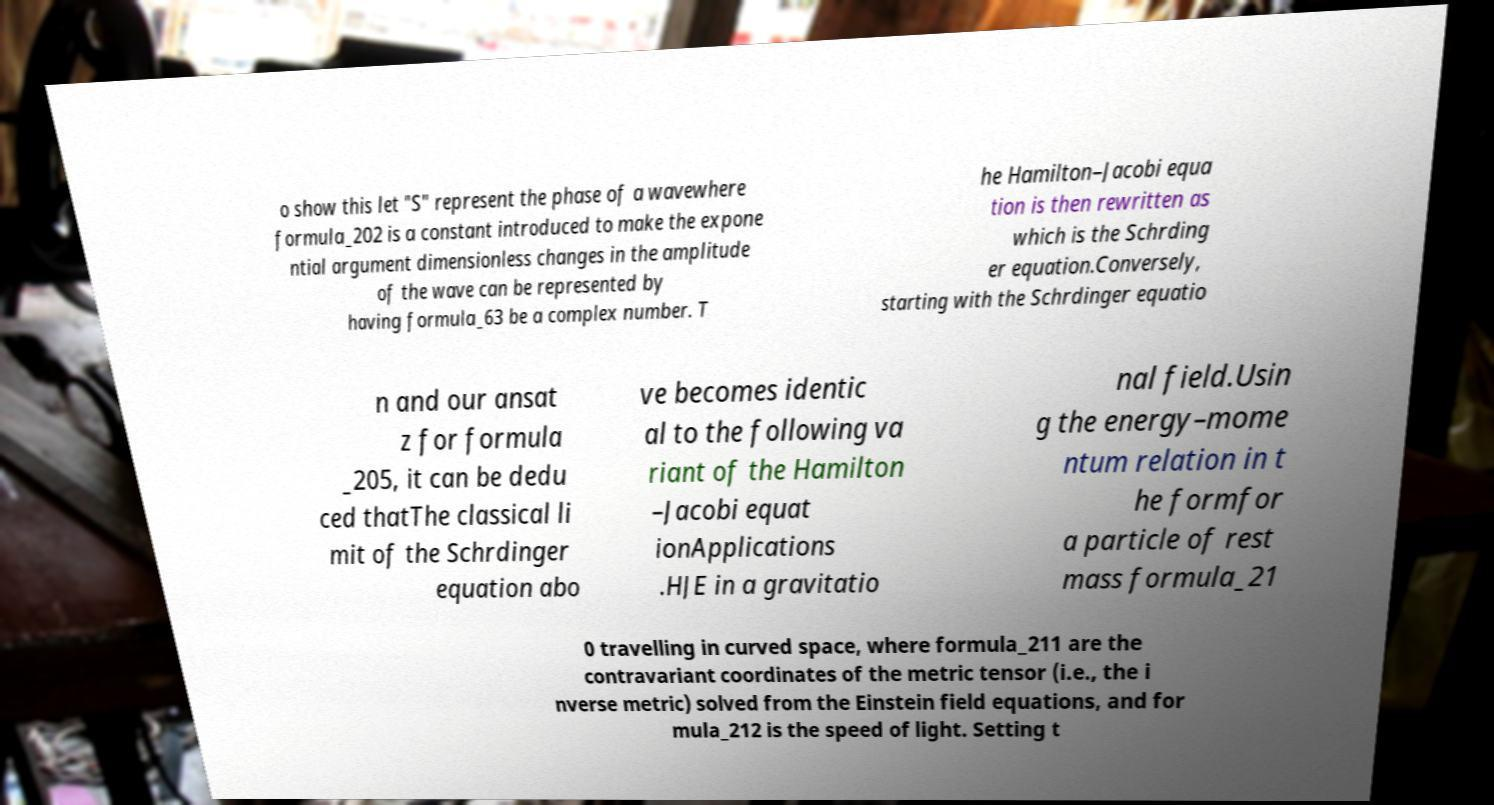For documentation purposes, I need the text within this image transcribed. Could you provide that? o show this let "S" represent the phase of a wavewhere formula_202 is a constant introduced to make the expone ntial argument dimensionless changes in the amplitude of the wave can be represented by having formula_63 be a complex number. T he Hamilton–Jacobi equa tion is then rewritten as which is the Schrding er equation.Conversely, starting with the Schrdinger equatio n and our ansat z for formula _205, it can be dedu ced thatThe classical li mit of the Schrdinger equation abo ve becomes identic al to the following va riant of the Hamilton –Jacobi equat ionApplications .HJE in a gravitatio nal field.Usin g the energy–mome ntum relation in t he formfor a particle of rest mass formula_21 0 travelling in curved space, where formula_211 are the contravariant coordinates of the metric tensor (i.e., the i nverse metric) solved from the Einstein field equations, and for mula_212 is the speed of light. Setting t 